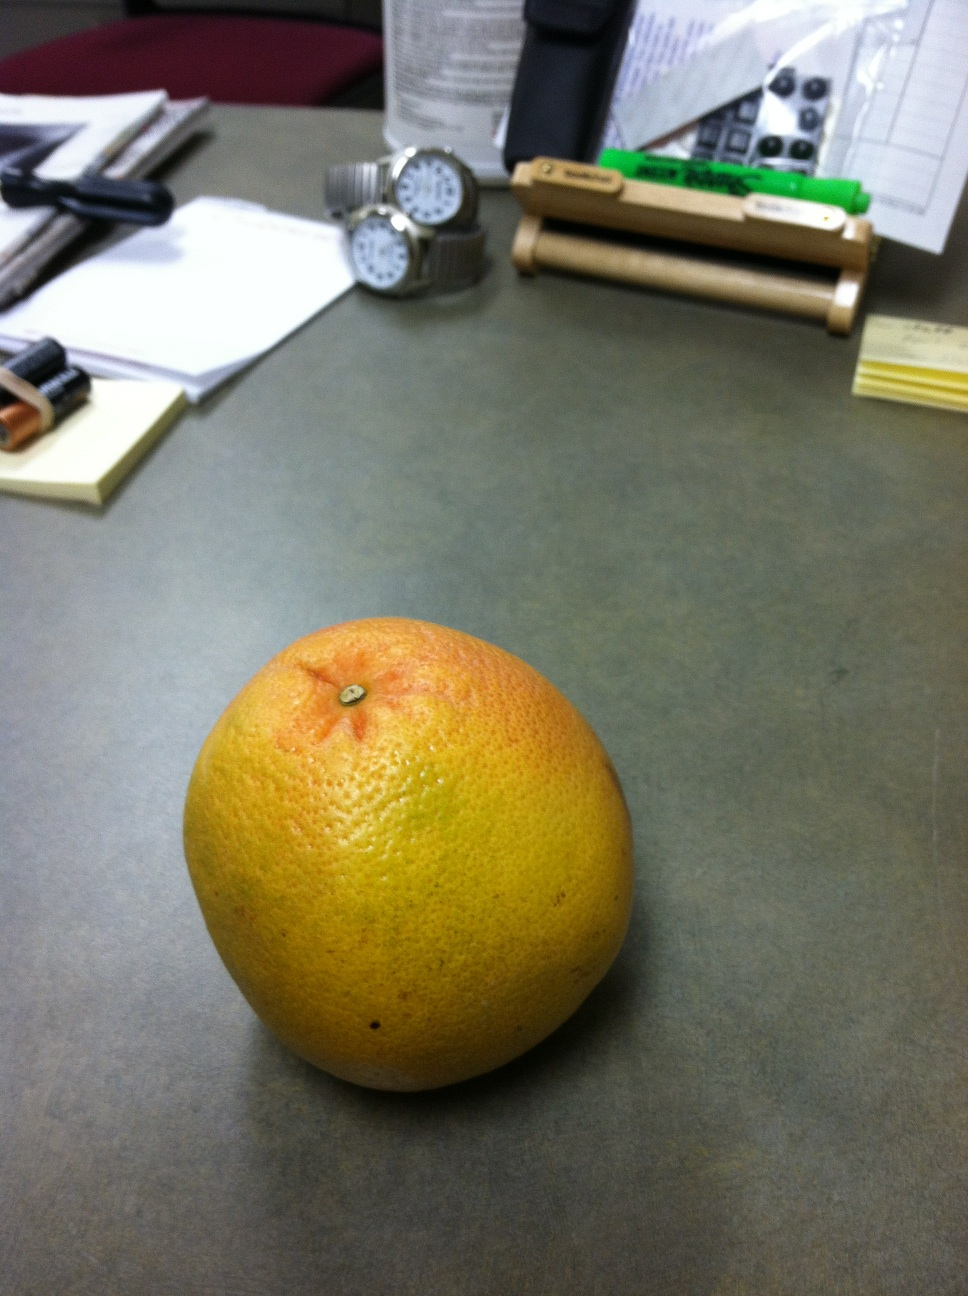If this desk could talk, what stories might it tell? If this desk could talk, it would share countless stories of determined work and fleeting moments of creativity. The desk has witnessed the swift strokes of a pen drafting reports late into the night, the anxious glances at the clock as deadlines loom, and the quiet moments of reflection as its owner indulges in healthy snacks like the grapefruit. It remembers the excitement of new ideas scribbled on sticky notes, the methodical arrangement of watches to keep track of time in different time zones, and the clang of batteries being replaced in essential devices. The desk has borne silent witness to phone calls that brought good news and some that brought challenges. It tells tales of a diligent worker finding balance between productivity and well-being, striving to maintain order amidst the chaos of a busy schedule. More than anything, the desk is a humble servant in the grand narrative of a committed individual navigating the demands of their life and work. 